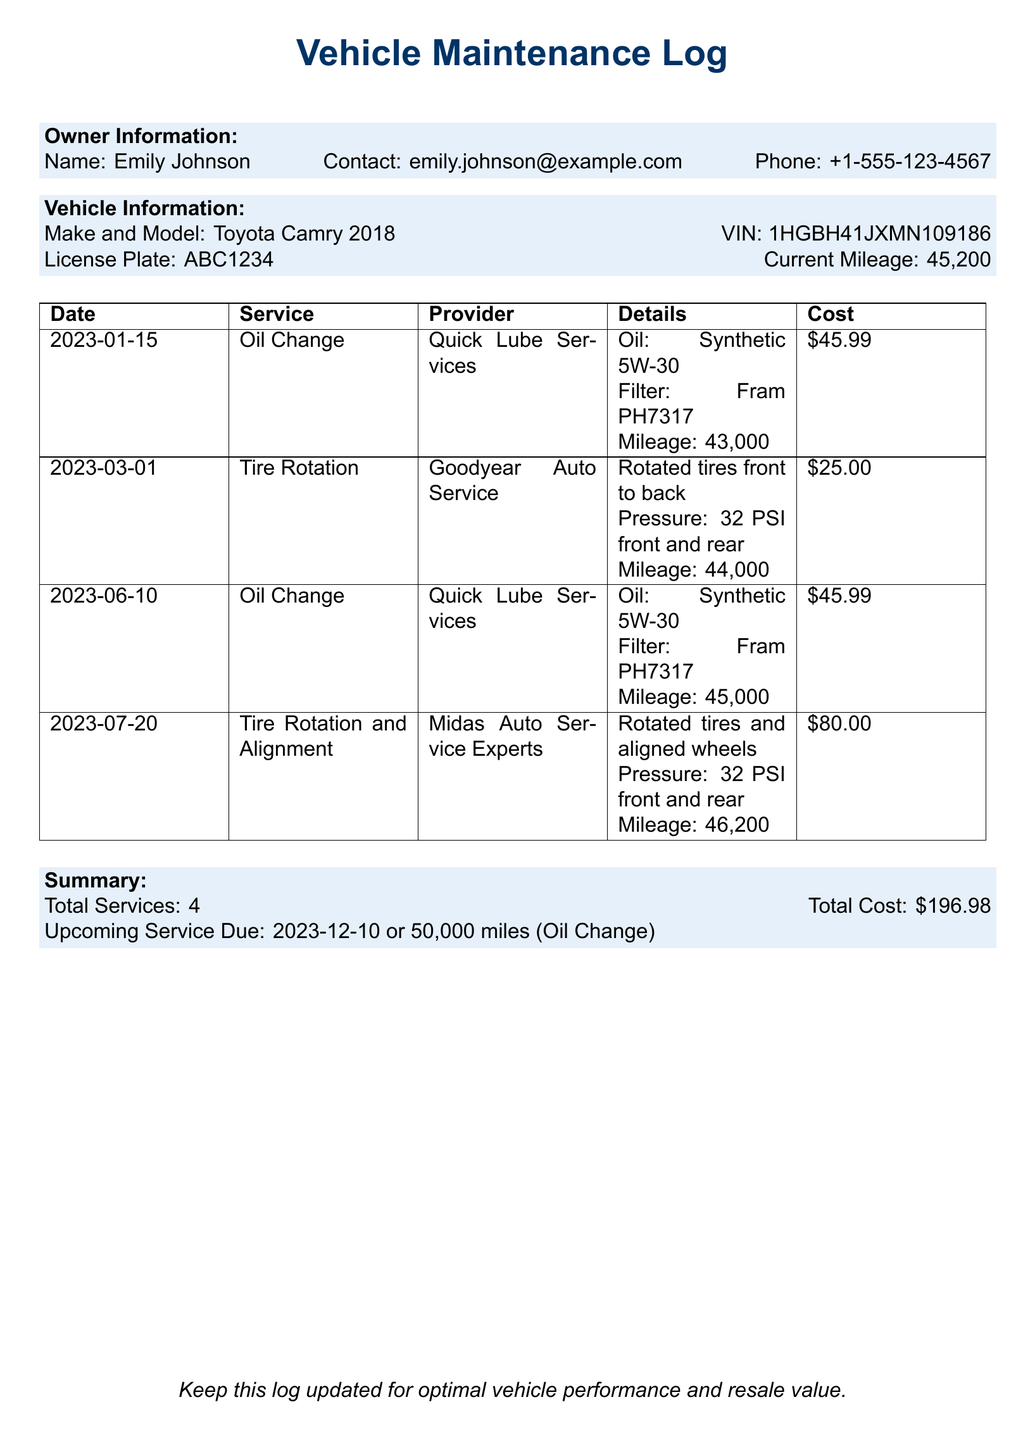What is the name of the vehicle owner? The name of the vehicle owner can be found in the owner information section of the document.
Answer: Emily Johnson What is the current mileage of the vehicle? The current mileage of the vehicle is noted in the vehicle information section of the document.
Answer: 45,200 What type of oil was used during the last oil change? The type of oil used can be found in the details of the last oil change entry.
Answer: Synthetic 5W-30 How much did the tire rotation on March 1, 2023, cost? The cost for the tire rotation service is mentioned in the corresponding entry.
Answer: $25.00 When is the next service due? The upcoming service due date is indicated in the summary section of the document.
Answer: 2023-12-10 What was the total cost for all services listed? The total cost is summarized at the end of the document.
Answer: $196.98 How many total services have been recorded? The total number of services is mentioned in the summary section of the document.
Answer: 4 Which service provider performed the last oil change? The service provider for the last oil change can be found in the details of the entry for that service.
Answer: Quick Lube Services What was included in the last tire service performed? The details of the last tire service entry describe what actions were taken during the service.
Answer: Rotated tires and aligned wheels 